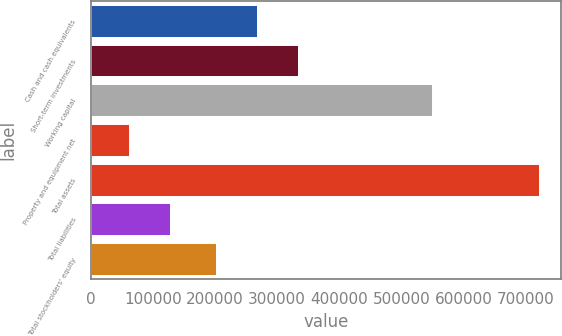Convert chart to OTSL. <chart><loc_0><loc_0><loc_500><loc_500><bar_chart><fcel>Cash and cash equivalents<fcel>Short-term investments<fcel>Working capital<fcel>Property and equipment net<fcel>Total assets<fcel>Total liabilities<fcel>Total stockholders' equity<nl><fcel>267707<fcel>333576<fcel>548324<fcel>61983<fcel>720675<fcel>127852<fcel>201838<nl></chart> 